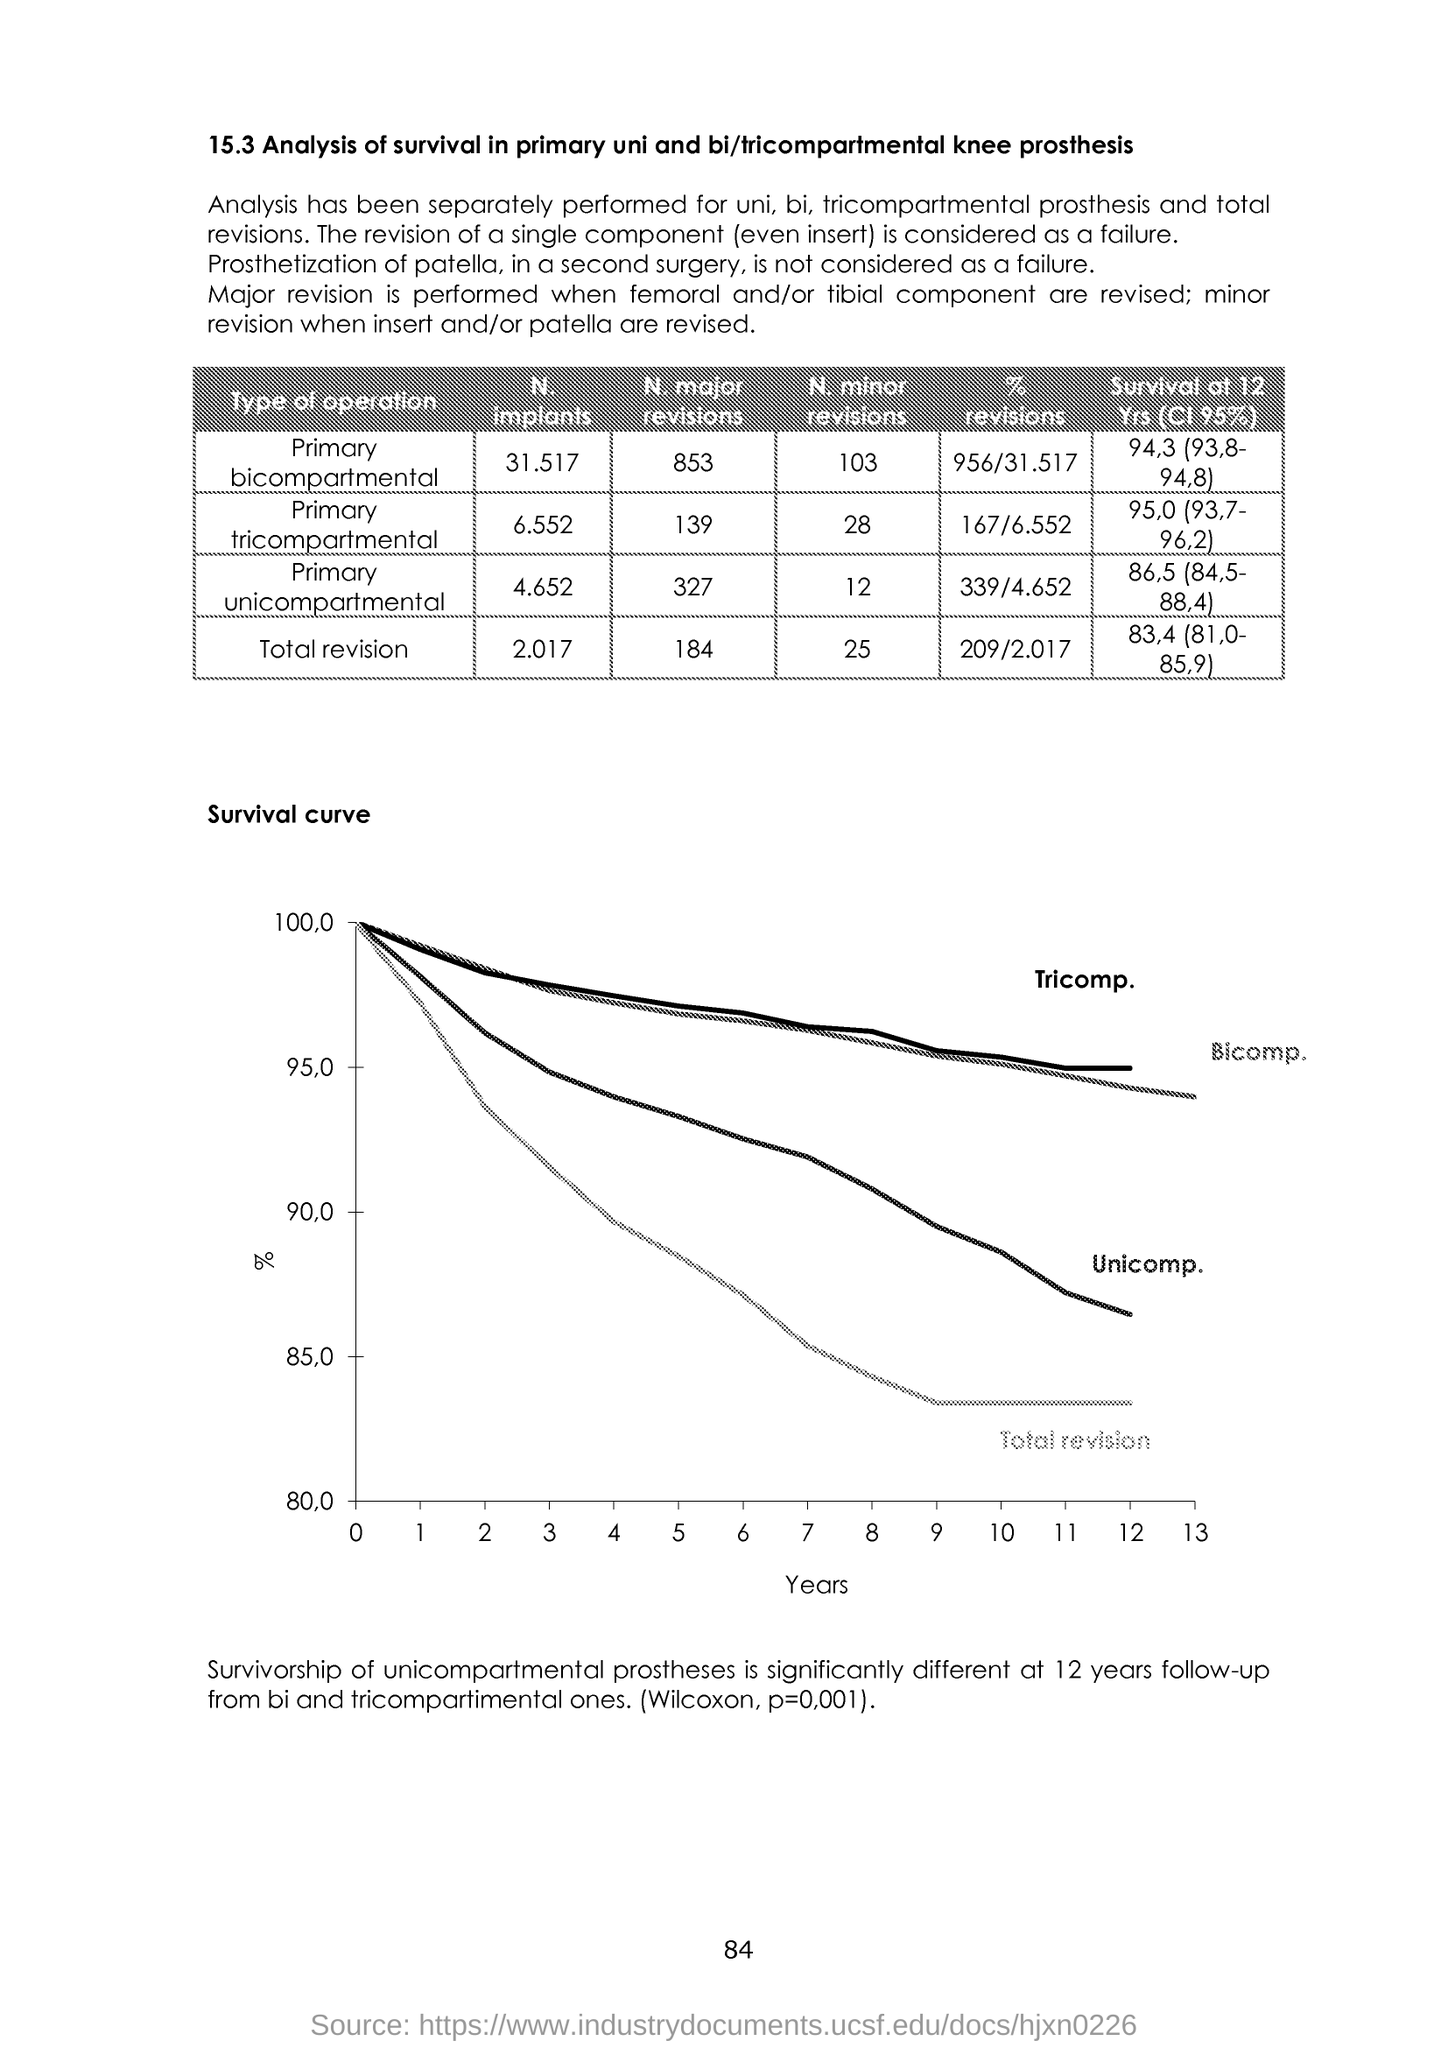What is plotted in the x-axis ?
Your response must be concise. Years. What is the Page Number?
Provide a short and direct response. 84. 